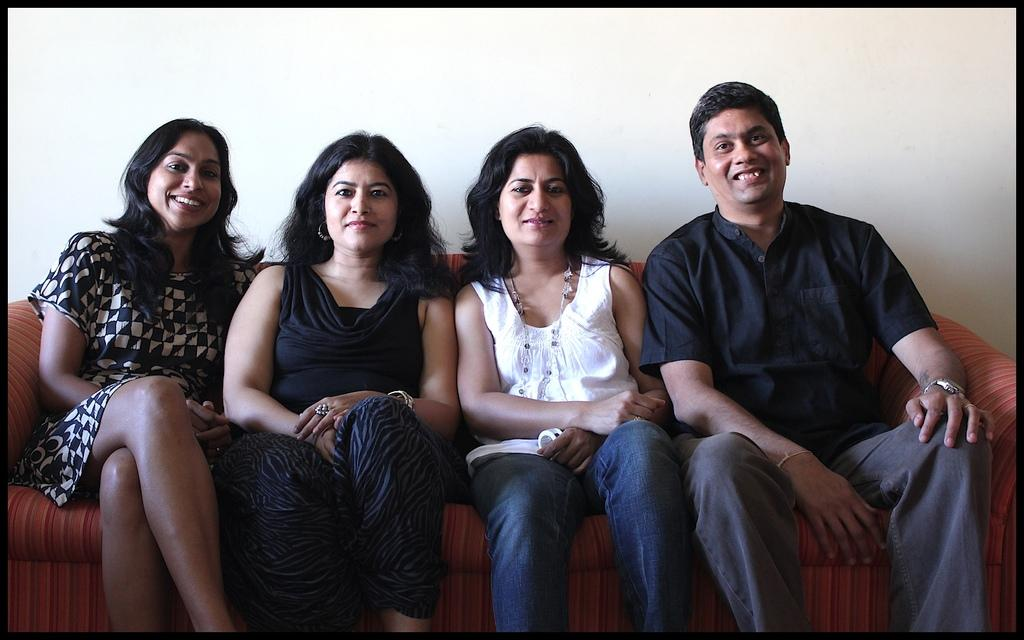How many people are in the image? There are four people in the image. What are the people doing in the image? The people are sitting on a sofa. What expressions do the people have in the image? The people have smiles on their faces. What can be seen in the background of the image? There is a wall visible in the background of the image. How many pies are on the sink in the image? There is no sink or pies present in the image. What are the people doing with their hands in the image? The provided facts do not mention the people's hands, so we cannot determine what they are doing with them. 